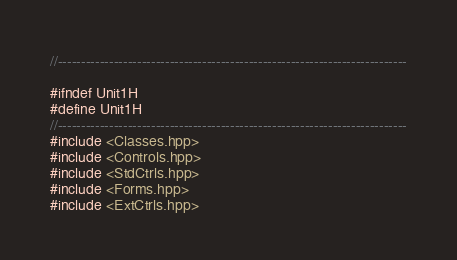<code> <loc_0><loc_0><loc_500><loc_500><_C_>//---------------------------------------------------------------------------

#ifndef Unit1H
#define Unit1H
//---------------------------------------------------------------------------
#include <Classes.hpp>
#include <Controls.hpp>
#include <StdCtrls.hpp>
#include <Forms.hpp>
#include <ExtCtrls.hpp></code> 